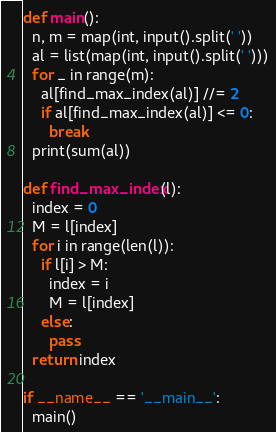<code> <loc_0><loc_0><loc_500><loc_500><_Python_>def main():
  n, m = map(int, input().split(' '))
  al = list(map(int, input().split(' ')))
  for _ in range(m):
    al[find_max_index(al)] //= 2
    if al[find_max_index(al)] <= 0:
      break
  print(sum(al))

def find_max_index(l):
  index = 0
  M = l[index]
  for i in range(len(l)):
    if l[i] > M:
      index = i
      M = l[index]
    else:
      pass
  return index

if __name__ == '__main__':
  main()
</code> 